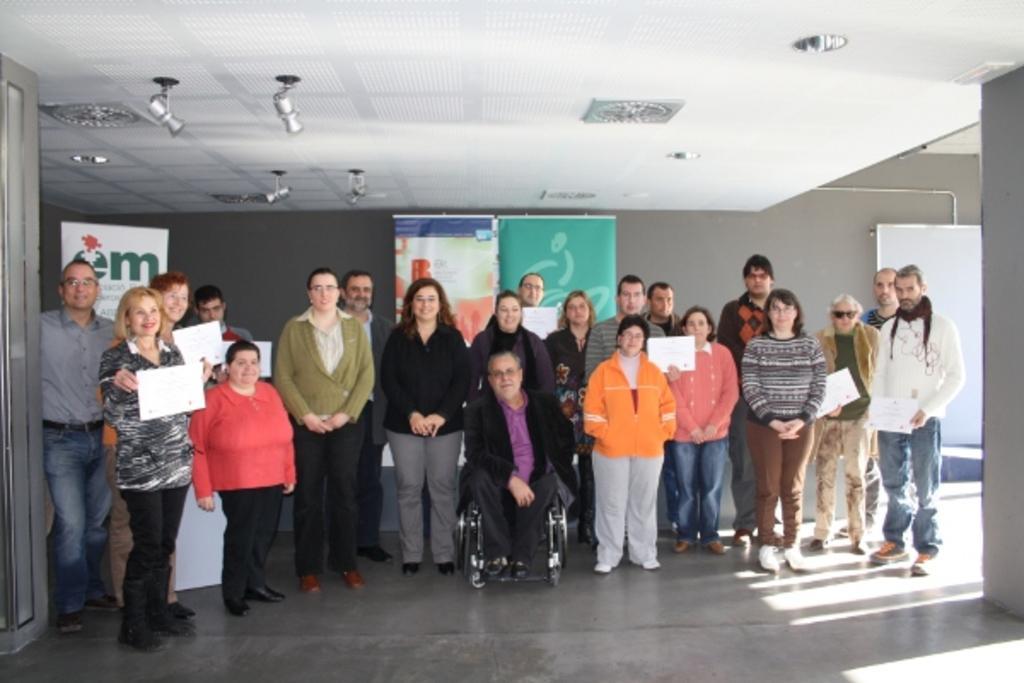How would you summarize this image in a sentence or two? In this picture there are group of persons standing where few among them are holding a certificate in their hands and there is a person sitting in a wheel chair in front of them and there are few banners behind them and there are few lights attached to the roof above them. 